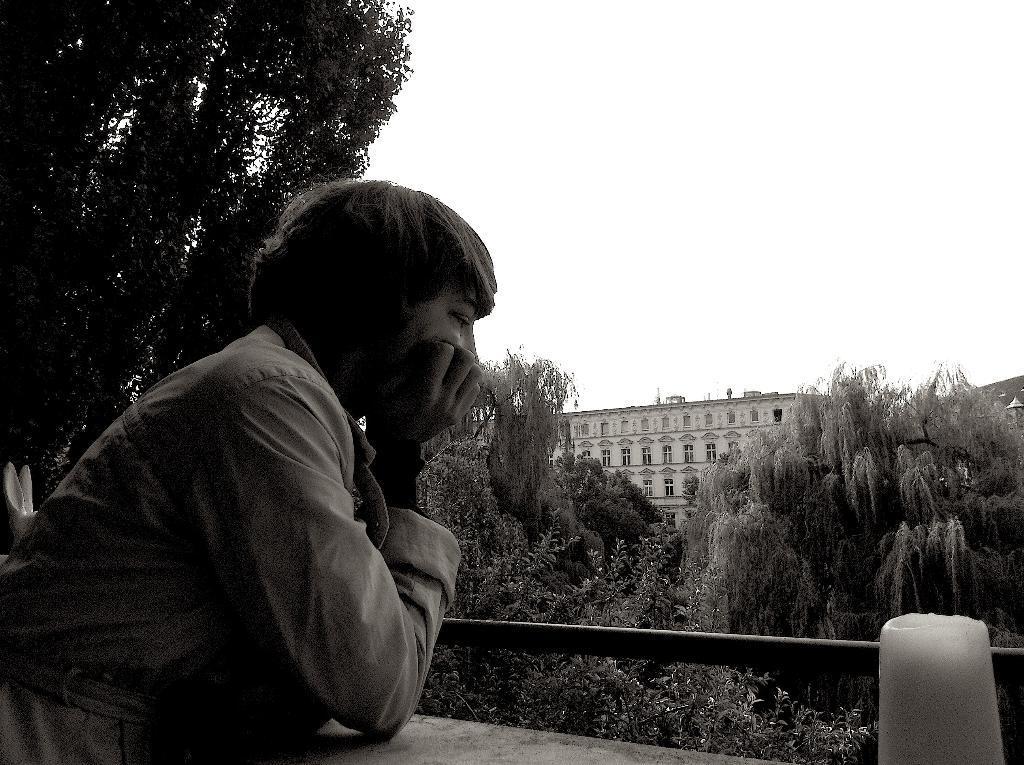Can you describe this image briefly? This is a black and white image and here we can see a person standing and in the background, there are trees, buildings and we can see some objects and there is a rod. At the top, there is sky. 